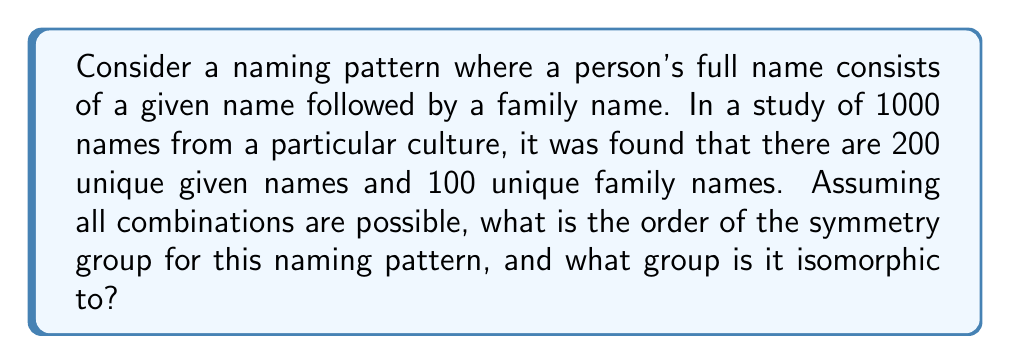Could you help me with this problem? To solve this problem, we'll follow these steps:

1) First, we need to understand what the symmetry group represents in this context. The symmetry group will consist of all possible permutations of the full names that preserve the structure (given name followed by family name).

2) The total number of possible full names is the product of the number of given names and family names:
   $$ 200 \times 100 = 20,000 $$

3) Now, we need to consider how we can permute these names while preserving the structure:
   - We can permute the given names among themselves (200! possibilities)
   - We can permute the family names among themselves (100! possibilities)

4) The total number of permutations is the product of these:
   $$ 200! \times 100! $$

5) This number represents the order of the symmetry group.

6) To identify the group, we need to recognize that this is a direct product of two symmetric groups:
   - $S_{200}$ (the symmetric group on 200 elements) for the given names
   - $S_{100}$ (the symmetric group on 100 elements) for the family names

7) Therefore, the symmetry group is isomorphic to:
   $$ S_{200} \times S_{100} $$
Answer: Order: $200! \times 100!$; Isomorphic to: $S_{200} \times S_{100}$ 